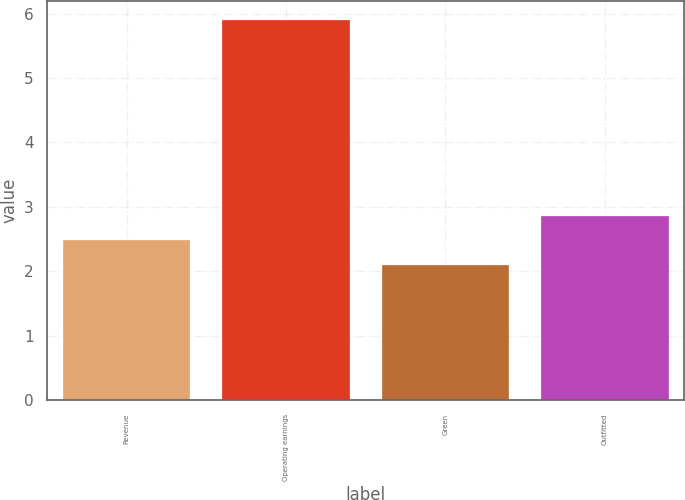Convert chart. <chart><loc_0><loc_0><loc_500><loc_500><bar_chart><fcel>Revenue<fcel>Operating earnings<fcel>Green<fcel>Outfitted<nl><fcel>2.48<fcel>5.9<fcel>2.1<fcel>2.86<nl></chart> 